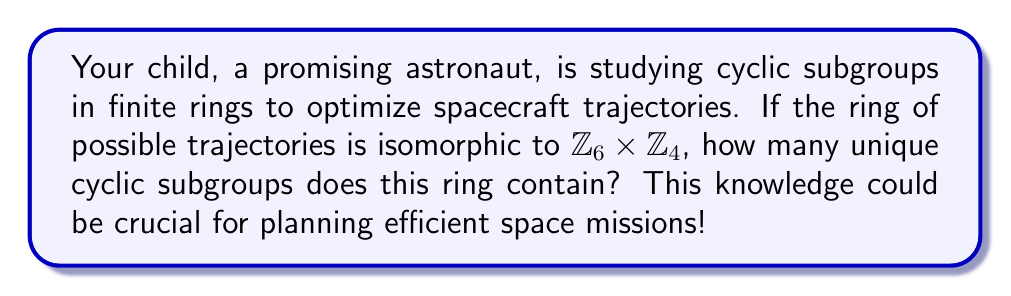Teach me how to tackle this problem. Let's approach this step-by-step:

1) First, recall that $\mathbb{Z}_6 \times \mathbb{Z}_4$ is a ring with 24 elements.

2) In a ring, cyclic subgroups are generated by single elements under addition.

3) To find the number of cyclic subgroups, we need to determine the order of each element in the ring.

4) The order of an element $(a,b)$ in $\mathbb{Z}_6 \times \mathbb{Z}_4$ is $lcm(ord_6(a), ord_4(b))$, where $ord_n(x)$ is the order of $x$ in $\mathbb{Z}_n$.

5) Let's list out the possible orders:
   - $(0,0)$ has order 1
   - Elements of the form $(0,b)$ where $b \neq 0$ have order 1, 2, or 4
   - Elements of the form $(a,0)$ where $a \neq 0$ have order 1, 2, 3, or 6
   - Other elements $(a,b)$ where $a \neq 0$ and $b \neq 0$ have order 12

6) Counting the number of elements of each order:
   - Order 1: 1 element
   - Order 2: 5 elements
   - Order 3: 2 elements
   - Order 4: 3 elements
   - Order 6: 2 elements
   - Order 12: 11 elements

7) Each element generates a cyclic subgroup, but elements in the same cyclic subgroup generate the same subgroup.

8) Therefore, the number of unique cyclic subgroups is:
   1 (order 1) + 3 (order 2) + 1 (order 3) + 1 (order 4) + 1 (order 6) + 1 (order 12) = 8

Thus, there are 8 unique cyclic subgroups in this ring.
Answer: 8 unique cyclic subgroups 